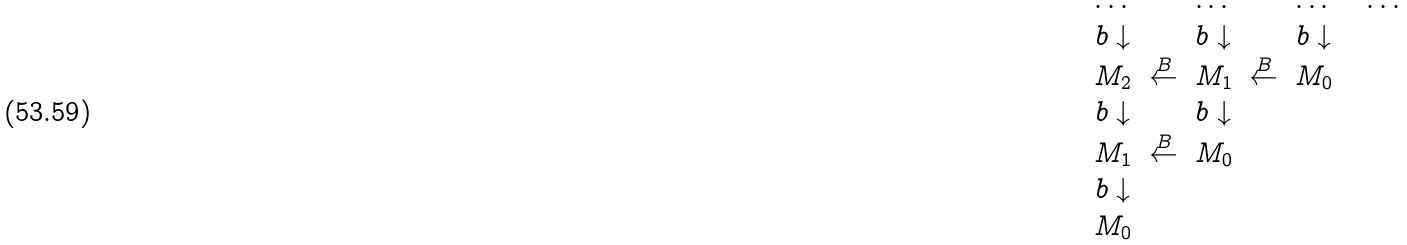<formula> <loc_0><loc_0><loc_500><loc_500>\begin{array} { c c c c c c c } \dots & & \dots & & \dots & & \dots \\ b \downarrow & & b \downarrow & & b \downarrow \\ M _ { 2 } & \stackrel { B } { \leftarrow } & M _ { 1 } & \stackrel { B } { \leftarrow } & M _ { 0 } \\ b \downarrow & & b \downarrow \\ M _ { 1 } & \stackrel { B } { \leftarrow } & M _ { 0 } \\ b \downarrow \\ M _ { 0 } \\ \end{array}</formula> 